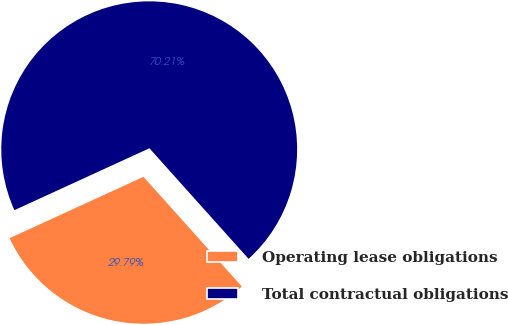Convert chart. <chart><loc_0><loc_0><loc_500><loc_500><pie_chart><fcel>Operating lease obligations<fcel>Total contractual obligations<nl><fcel>29.79%<fcel>70.21%<nl></chart> 